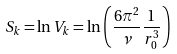<formula> <loc_0><loc_0><loc_500><loc_500>S _ { k } = \ln V _ { k } = \ln \left ( \frac { 6 \pi ^ { 2 } } { \nu } \frac { 1 } { r _ { 0 } ^ { 3 } } \right )</formula> 